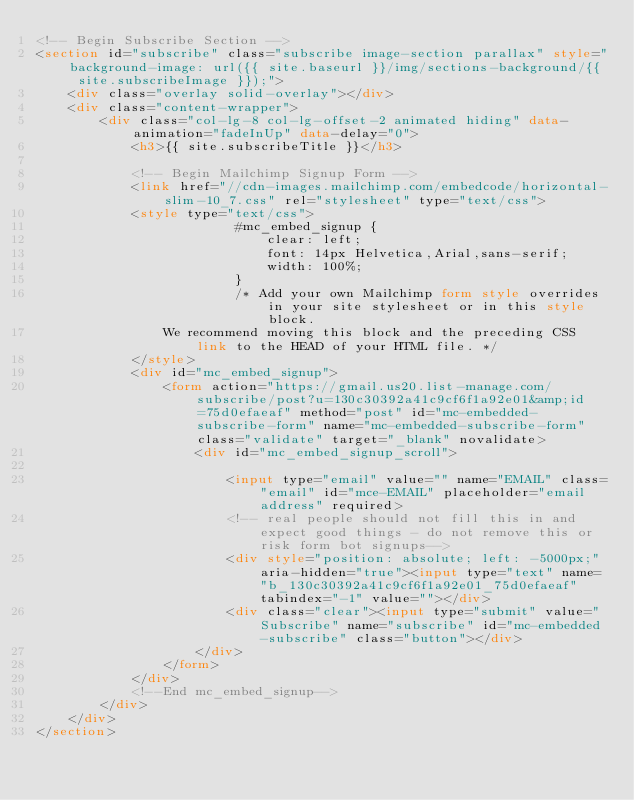<code> <loc_0><loc_0><loc_500><loc_500><_HTML_><!-- Begin Subscribe Section -->
<section id="subscribe" class="subscribe image-section parallax" style="background-image: url({{ site.baseurl }}/img/sections-background/{{ site.subscribeImage }});">
    <div class="overlay solid-overlay"></div>
    <div class="content-wrapper">
        <div class="col-lg-8 col-lg-offset-2 animated hiding" data-animation="fadeInUp" data-delay="0">
            <h3>{{ site.subscribeTitle }}</h3>

            <!-- Begin Mailchimp Signup Form -->
            <link href="//cdn-images.mailchimp.com/embedcode/horizontal-slim-10_7.css" rel="stylesheet" type="text/css">
            <style type="text/css">
                         #mc_embed_signup {
                             clear: left;
                             font: 14px Helvetica,Arial,sans-serif;
                             width: 100%;
                         }
                         /* Add your own Mailchimp form style overrides in your site stylesheet or in this style block.
                We recommend moving this block and the preceding CSS link to the HEAD of your HTML file. */
            </style>
            <div id="mc_embed_signup">
                <form action="https://gmail.us20.list-manage.com/subscribe/post?u=130c30392a41c9cf6f1a92e01&amp;id=75d0efaeaf" method="post" id="mc-embedded-subscribe-form" name="mc-embedded-subscribe-form" class="validate" target="_blank" novalidate>
                    <div id="mc_embed_signup_scroll">

                        <input type="email" value="" name="EMAIL" class="email" id="mce-EMAIL" placeholder="email address" required>
                        <!-- real people should not fill this in and expect good things - do not remove this or risk form bot signups-->
                        <div style="position: absolute; left: -5000px;" aria-hidden="true"><input type="text" name="b_130c30392a41c9cf6f1a92e01_75d0efaeaf" tabindex="-1" value=""></div>
                        <div class="clear"><input type="submit" value="Subscribe" name="subscribe" id="mc-embedded-subscribe" class="button"></div>
                    </div>
                </form>
            </div>
            <!--End mc_embed_signup-->
        </div>
    </div>
</section></code> 